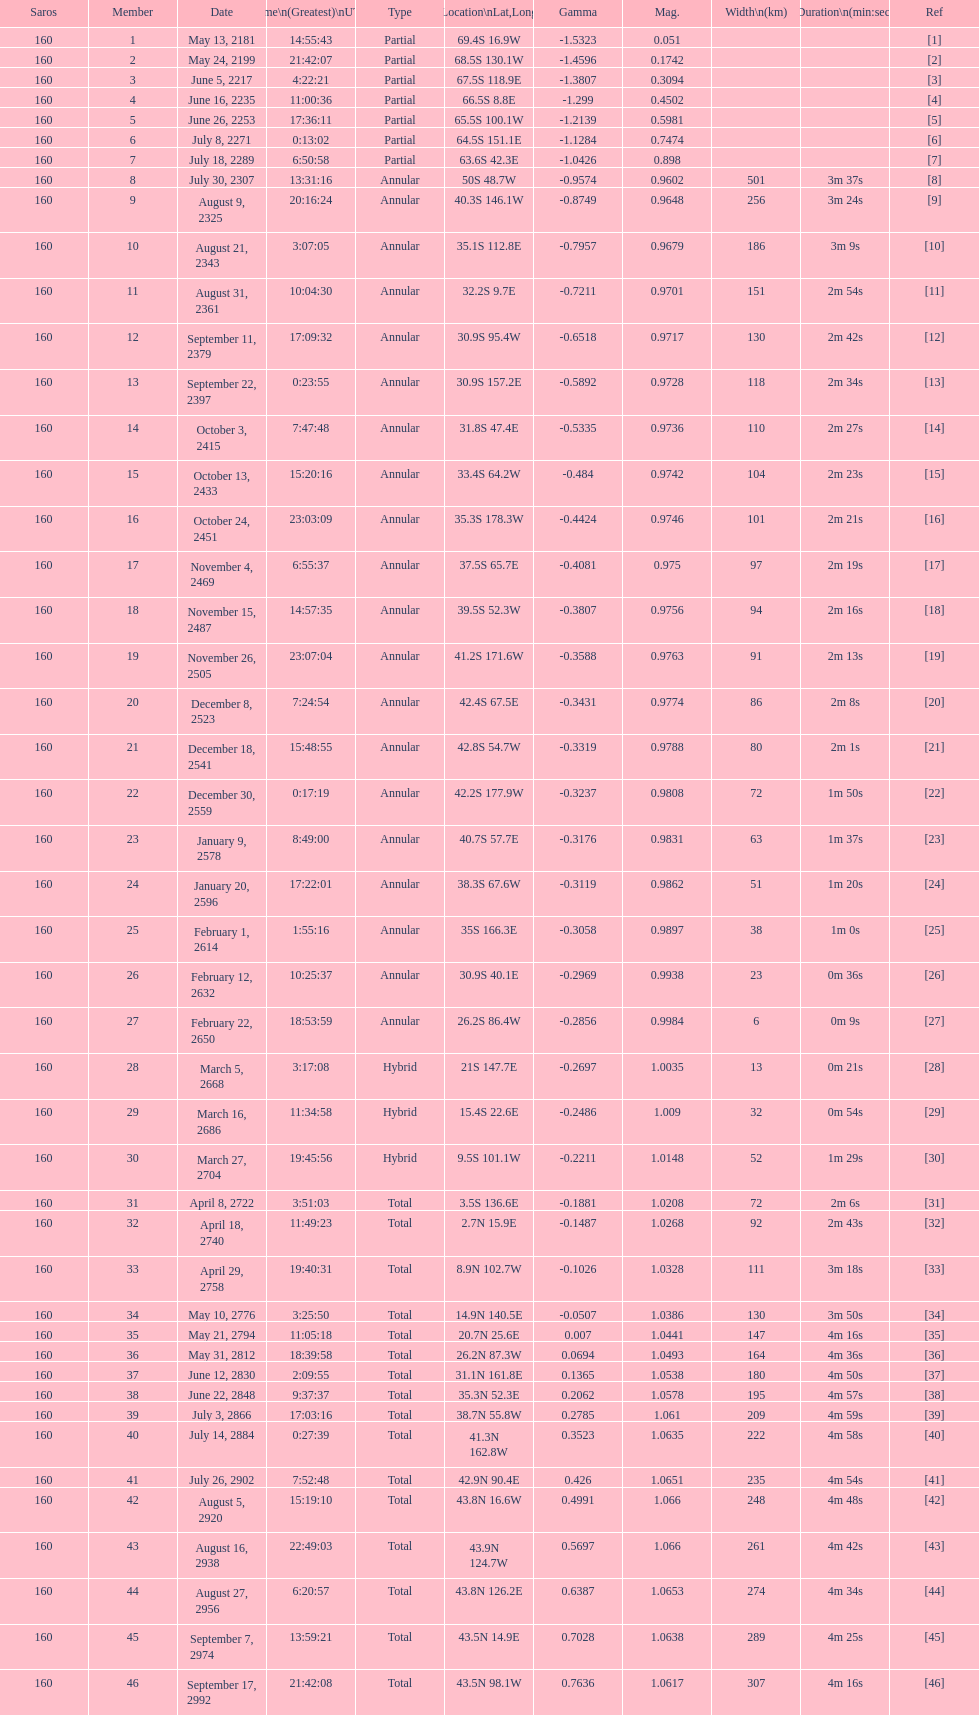Could you parse the entire table as a dict? {'header': ['Saros', 'Member', 'Date', 'Time\\n(Greatest)\\nUTC', 'Type', 'Location\\nLat,Long', 'Gamma', 'Mag.', 'Width\\n(km)', 'Duration\\n(min:sec)', 'Ref'], 'rows': [['160', '1', 'May 13, 2181', '14:55:43', 'Partial', '69.4S 16.9W', '-1.5323', '0.051', '', '', '[1]'], ['160', '2', 'May 24, 2199', '21:42:07', 'Partial', '68.5S 130.1W', '-1.4596', '0.1742', '', '', '[2]'], ['160', '3', 'June 5, 2217', '4:22:21', 'Partial', '67.5S 118.9E', '-1.3807', '0.3094', '', '', '[3]'], ['160', '4', 'June 16, 2235', '11:00:36', 'Partial', '66.5S 8.8E', '-1.299', '0.4502', '', '', '[4]'], ['160', '5', 'June 26, 2253', '17:36:11', 'Partial', '65.5S 100.1W', '-1.2139', '0.5981', '', '', '[5]'], ['160', '6', 'July 8, 2271', '0:13:02', 'Partial', '64.5S 151.1E', '-1.1284', '0.7474', '', '', '[6]'], ['160', '7', 'July 18, 2289', '6:50:58', 'Partial', '63.6S 42.3E', '-1.0426', '0.898', '', '', '[7]'], ['160', '8', 'July 30, 2307', '13:31:16', 'Annular', '50S 48.7W', '-0.9574', '0.9602', '501', '3m 37s', '[8]'], ['160', '9', 'August 9, 2325', '20:16:24', 'Annular', '40.3S 146.1W', '-0.8749', '0.9648', '256', '3m 24s', '[9]'], ['160', '10', 'August 21, 2343', '3:07:05', 'Annular', '35.1S 112.8E', '-0.7957', '0.9679', '186', '3m 9s', '[10]'], ['160', '11', 'August 31, 2361', '10:04:30', 'Annular', '32.2S 9.7E', '-0.7211', '0.9701', '151', '2m 54s', '[11]'], ['160', '12', 'September 11, 2379', '17:09:32', 'Annular', '30.9S 95.4W', '-0.6518', '0.9717', '130', '2m 42s', '[12]'], ['160', '13', 'September 22, 2397', '0:23:55', 'Annular', '30.9S 157.2E', '-0.5892', '0.9728', '118', '2m 34s', '[13]'], ['160', '14', 'October 3, 2415', '7:47:48', 'Annular', '31.8S 47.4E', '-0.5335', '0.9736', '110', '2m 27s', '[14]'], ['160', '15', 'October 13, 2433', '15:20:16', 'Annular', '33.4S 64.2W', '-0.484', '0.9742', '104', '2m 23s', '[15]'], ['160', '16', 'October 24, 2451', '23:03:09', 'Annular', '35.3S 178.3W', '-0.4424', '0.9746', '101', '2m 21s', '[16]'], ['160', '17', 'November 4, 2469', '6:55:37', 'Annular', '37.5S 65.7E', '-0.4081', '0.975', '97', '2m 19s', '[17]'], ['160', '18', 'November 15, 2487', '14:57:35', 'Annular', '39.5S 52.3W', '-0.3807', '0.9756', '94', '2m 16s', '[18]'], ['160', '19', 'November 26, 2505', '23:07:04', 'Annular', '41.2S 171.6W', '-0.3588', '0.9763', '91', '2m 13s', '[19]'], ['160', '20', 'December 8, 2523', '7:24:54', 'Annular', '42.4S 67.5E', '-0.3431', '0.9774', '86', '2m 8s', '[20]'], ['160', '21', 'December 18, 2541', '15:48:55', 'Annular', '42.8S 54.7W', '-0.3319', '0.9788', '80', '2m 1s', '[21]'], ['160', '22', 'December 30, 2559', '0:17:19', 'Annular', '42.2S 177.9W', '-0.3237', '0.9808', '72', '1m 50s', '[22]'], ['160', '23', 'January 9, 2578', '8:49:00', 'Annular', '40.7S 57.7E', '-0.3176', '0.9831', '63', '1m 37s', '[23]'], ['160', '24', 'January 20, 2596', '17:22:01', 'Annular', '38.3S 67.6W', '-0.3119', '0.9862', '51', '1m 20s', '[24]'], ['160', '25', 'February 1, 2614', '1:55:16', 'Annular', '35S 166.3E', '-0.3058', '0.9897', '38', '1m 0s', '[25]'], ['160', '26', 'February 12, 2632', '10:25:37', 'Annular', '30.9S 40.1E', '-0.2969', '0.9938', '23', '0m 36s', '[26]'], ['160', '27', 'February 22, 2650', '18:53:59', 'Annular', '26.2S 86.4W', '-0.2856', '0.9984', '6', '0m 9s', '[27]'], ['160', '28', 'March 5, 2668', '3:17:08', 'Hybrid', '21S 147.7E', '-0.2697', '1.0035', '13', '0m 21s', '[28]'], ['160', '29', 'March 16, 2686', '11:34:58', 'Hybrid', '15.4S 22.6E', '-0.2486', '1.009', '32', '0m 54s', '[29]'], ['160', '30', 'March 27, 2704', '19:45:56', 'Hybrid', '9.5S 101.1W', '-0.2211', '1.0148', '52', '1m 29s', '[30]'], ['160', '31', 'April 8, 2722', '3:51:03', 'Total', '3.5S 136.6E', '-0.1881', '1.0208', '72', '2m 6s', '[31]'], ['160', '32', 'April 18, 2740', '11:49:23', 'Total', '2.7N 15.9E', '-0.1487', '1.0268', '92', '2m 43s', '[32]'], ['160', '33', 'April 29, 2758', '19:40:31', 'Total', '8.9N 102.7W', '-0.1026', '1.0328', '111', '3m 18s', '[33]'], ['160', '34', 'May 10, 2776', '3:25:50', 'Total', '14.9N 140.5E', '-0.0507', '1.0386', '130', '3m 50s', '[34]'], ['160', '35', 'May 21, 2794', '11:05:18', 'Total', '20.7N 25.6E', '0.007', '1.0441', '147', '4m 16s', '[35]'], ['160', '36', 'May 31, 2812', '18:39:58', 'Total', '26.2N 87.3W', '0.0694', '1.0493', '164', '4m 36s', '[36]'], ['160', '37', 'June 12, 2830', '2:09:55', 'Total', '31.1N 161.8E', '0.1365', '1.0538', '180', '4m 50s', '[37]'], ['160', '38', 'June 22, 2848', '9:37:37', 'Total', '35.3N 52.3E', '0.2062', '1.0578', '195', '4m 57s', '[38]'], ['160', '39', 'July 3, 2866', '17:03:16', 'Total', '38.7N 55.8W', '0.2785', '1.061', '209', '4m 59s', '[39]'], ['160', '40', 'July 14, 2884', '0:27:39', 'Total', '41.3N 162.8W', '0.3523', '1.0635', '222', '4m 58s', '[40]'], ['160', '41', 'July 26, 2902', '7:52:48', 'Total', '42.9N 90.4E', '0.426', '1.0651', '235', '4m 54s', '[41]'], ['160', '42', 'August 5, 2920', '15:19:10', 'Total', '43.8N 16.6W', '0.4991', '1.066', '248', '4m 48s', '[42]'], ['160', '43', 'August 16, 2938', '22:49:03', 'Total', '43.9N 124.7W', '0.5697', '1.066', '261', '4m 42s', '[43]'], ['160', '44', 'August 27, 2956', '6:20:57', 'Total', '43.8N 126.2E', '0.6387', '1.0653', '274', '4m 34s', '[44]'], ['160', '45', 'September 7, 2974', '13:59:21', 'Total', '43.5N 14.9E', '0.7028', '1.0638', '289', '4m 25s', '[45]'], ['160', '46', 'September 17, 2992', '21:42:08', 'Total', '43.5N 98.1W', '0.7636', '1.0617', '307', '4m 16s', '[46]']]} Name one that has the same latitude as member number 12. 13. 